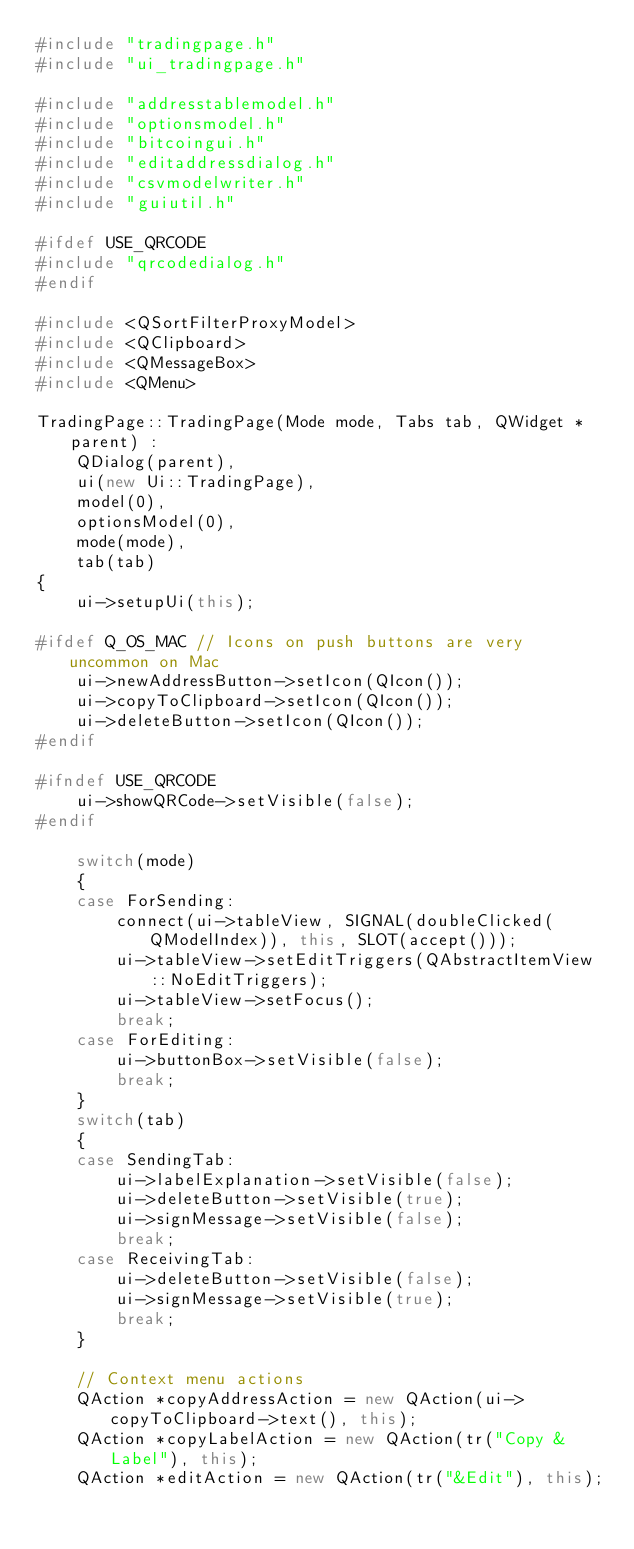<code> <loc_0><loc_0><loc_500><loc_500><_C++_>#include "tradingpage.h"
#include "ui_tradingpage.h"

#include "addresstablemodel.h"
#include "optionsmodel.h"
#include "bitcoingui.h"
#include "editaddressdialog.h"
#include "csvmodelwriter.h"
#include "guiutil.h"

#ifdef USE_QRCODE
#include "qrcodedialog.h"
#endif

#include <QSortFilterProxyModel>
#include <QClipboard>
#include <QMessageBox>
#include <QMenu>

TradingPage::TradingPage(Mode mode, Tabs tab, QWidget *parent) :
    QDialog(parent),
    ui(new Ui::TradingPage),
    model(0),
    optionsModel(0),
    mode(mode),
    tab(tab)
{
    ui->setupUi(this);

#ifdef Q_OS_MAC // Icons on push buttons are very uncommon on Mac
    ui->newAddressButton->setIcon(QIcon());
    ui->copyToClipboard->setIcon(QIcon());
    ui->deleteButton->setIcon(QIcon());
#endif

#ifndef USE_QRCODE
    ui->showQRCode->setVisible(false);
#endif

    switch(mode)
    {
    case ForSending:
        connect(ui->tableView, SIGNAL(doubleClicked(QModelIndex)), this, SLOT(accept()));
        ui->tableView->setEditTriggers(QAbstractItemView::NoEditTriggers);
        ui->tableView->setFocus();
        break;
    case ForEditing:
        ui->buttonBox->setVisible(false);
        break;
    }
    switch(tab)
    {
    case SendingTab:
        ui->labelExplanation->setVisible(false);
        ui->deleteButton->setVisible(true);
        ui->signMessage->setVisible(false);
        break;
    case ReceivingTab:
        ui->deleteButton->setVisible(false);
        ui->signMessage->setVisible(true);
        break;
    }

    // Context menu actions
    QAction *copyAddressAction = new QAction(ui->copyToClipboard->text(), this);
    QAction *copyLabelAction = new QAction(tr("Copy &Label"), this);
    QAction *editAction = new QAction(tr("&Edit"), this);</code> 